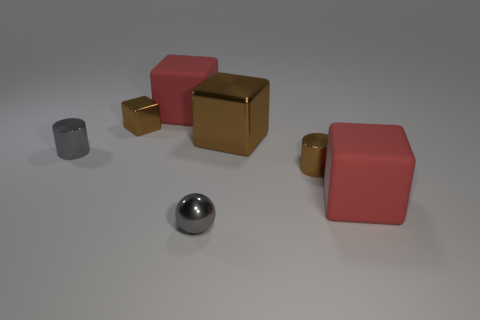Add 1 large blue metal spheres. How many objects exist? 8 Subtract all large cubes. How many cubes are left? 1 Subtract all red cubes. How many cubes are left? 2 Add 1 large red objects. How many large red objects exist? 3 Subtract 1 gray cylinders. How many objects are left? 6 Subtract all balls. How many objects are left? 6 Subtract 1 cylinders. How many cylinders are left? 1 Subtract all brown blocks. Subtract all blue spheres. How many blocks are left? 2 Subtract all blue balls. How many red blocks are left? 2 Subtract all big red blocks. Subtract all big shiny objects. How many objects are left? 4 